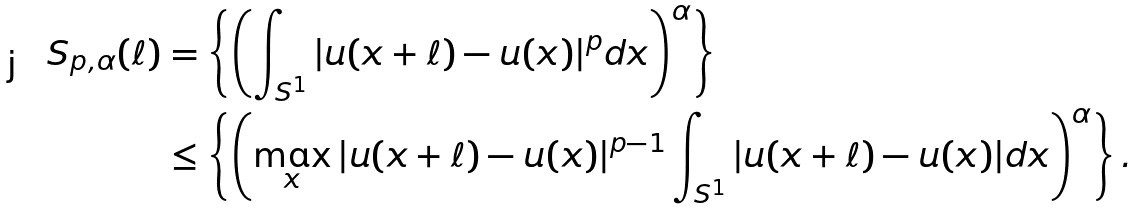<formula> <loc_0><loc_0><loc_500><loc_500>S _ { p , \alpha } ( \ell ) & = \left \{ \left ( \int _ { S ^ { 1 } } { | u ( x + \ell ) - u ( x ) | ^ { p } d x } \right ) ^ { \alpha } \right \} \\ & \leq \left \{ \left ( \max _ { x } | u ( x + \ell ) - u ( x ) | ^ { p - 1 } \int _ { S ^ { 1 } } { | u ( x + \ell ) - u ( x ) | d x } \right ) ^ { \alpha } \right \} .</formula> 